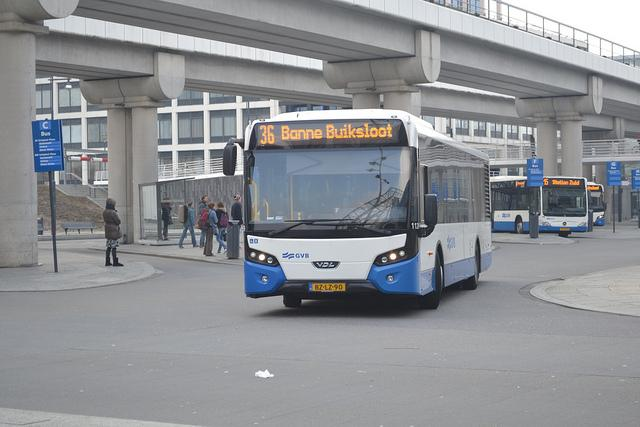Where are these people probably waiting to catch a bus? bus stop 